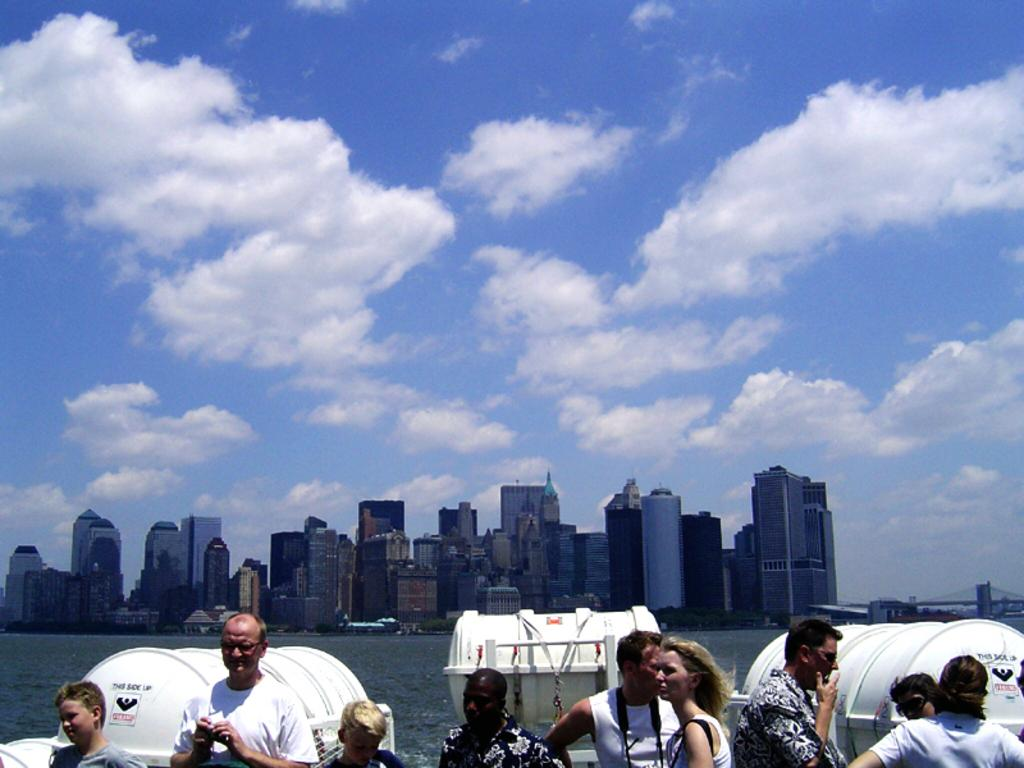What is the main element present in the image? There is water in the image. What type of structures can be seen in the image? There are buildings and a bridge in the image. What objects are related to safety in the image? There are lifeboat barrels in the image. Who or what is located at the bottom of the image? There are people at the bottom of the image. What can be seen in the background of the image? The sky is visible in the background of the image. What type of spring is visible in the image? There is no spring present in the image; it features water, buildings, a bridge, lifeboat barrels, people, and the sky. Is there a party happening in the image? There is no indication of a party in the image; it shows a scene with water, buildings, a bridge, lifeboat barrels, people, and the sky. 